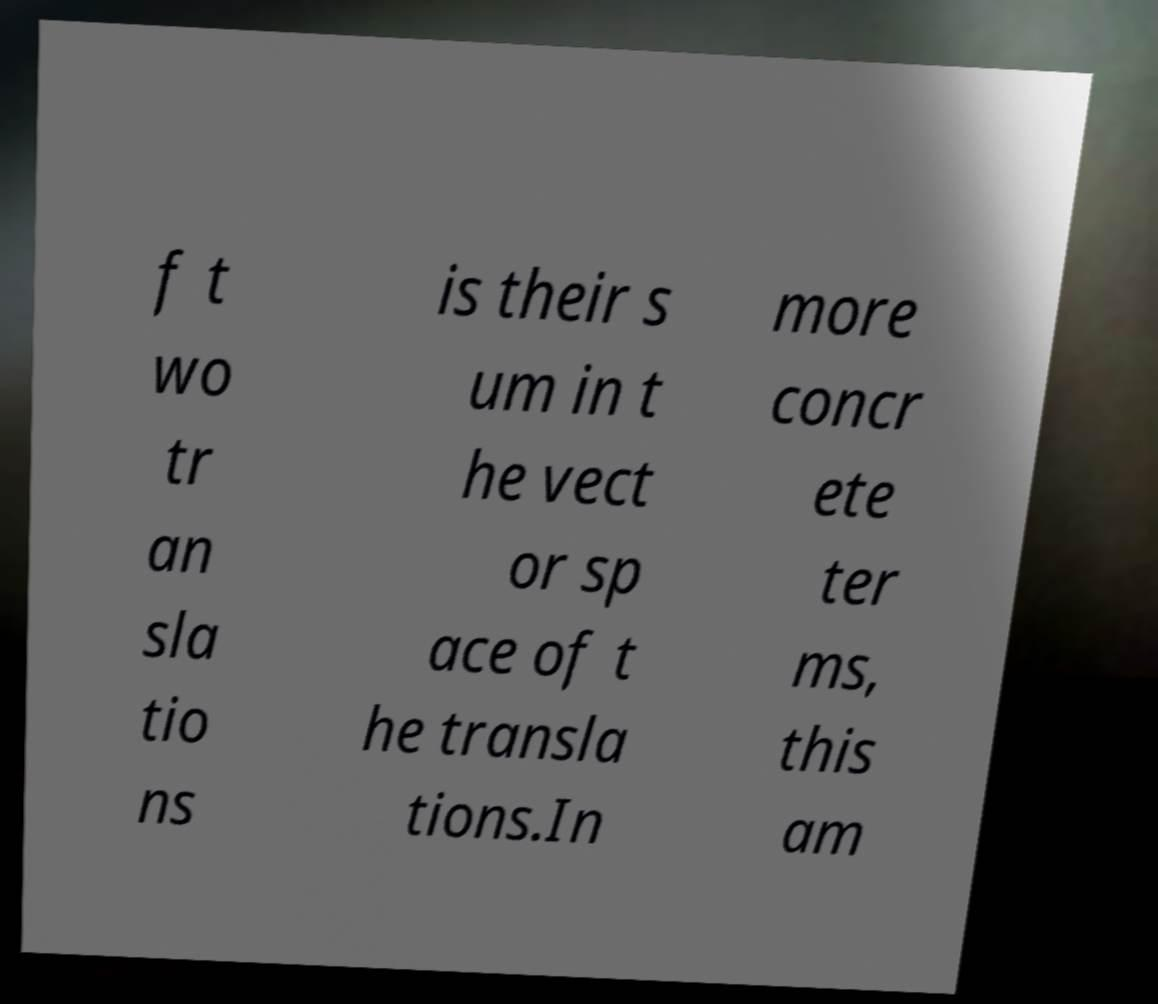Can you accurately transcribe the text from the provided image for me? f t wo tr an sla tio ns is their s um in t he vect or sp ace of t he transla tions.In more concr ete ter ms, this am 